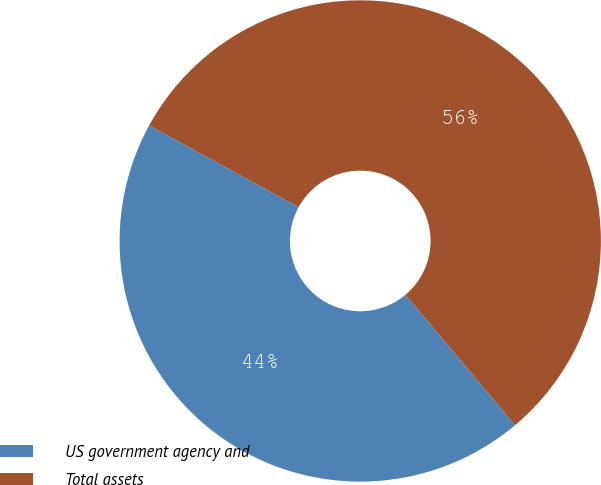<chart> <loc_0><loc_0><loc_500><loc_500><pie_chart><fcel>US government agency and<fcel>Total assets<nl><fcel>44.09%<fcel>55.91%<nl></chart> 